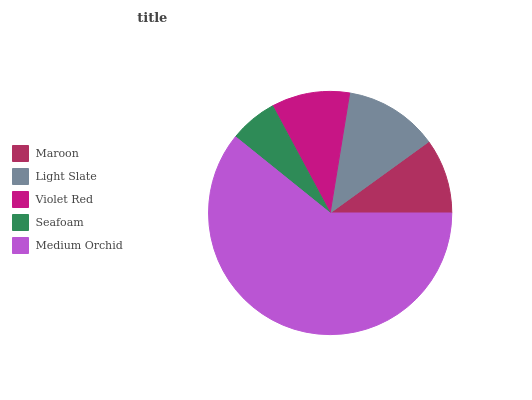Is Seafoam the minimum?
Answer yes or no. Yes. Is Medium Orchid the maximum?
Answer yes or no. Yes. Is Light Slate the minimum?
Answer yes or no. No. Is Light Slate the maximum?
Answer yes or no. No. Is Light Slate greater than Maroon?
Answer yes or no. Yes. Is Maroon less than Light Slate?
Answer yes or no. Yes. Is Maroon greater than Light Slate?
Answer yes or no. No. Is Light Slate less than Maroon?
Answer yes or no. No. Is Violet Red the high median?
Answer yes or no. Yes. Is Violet Red the low median?
Answer yes or no. Yes. Is Maroon the high median?
Answer yes or no. No. Is Seafoam the low median?
Answer yes or no. No. 